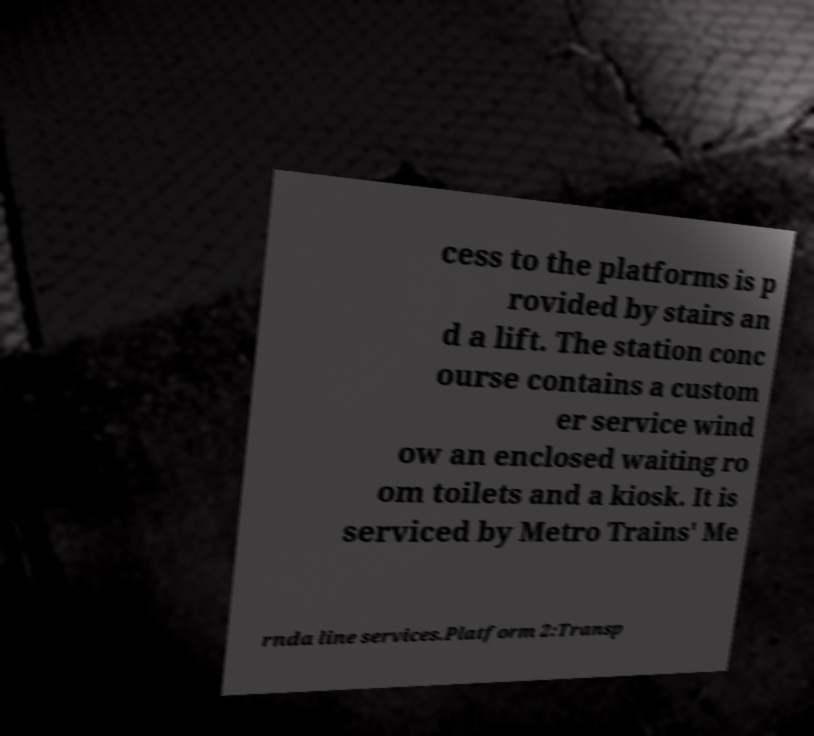I need the written content from this picture converted into text. Can you do that? cess to the platforms is p rovided by stairs an d a lift. The station conc ourse contains a custom er service wind ow an enclosed waiting ro om toilets and a kiosk. It is serviced by Metro Trains' Me rnda line services.Platform 2:Transp 